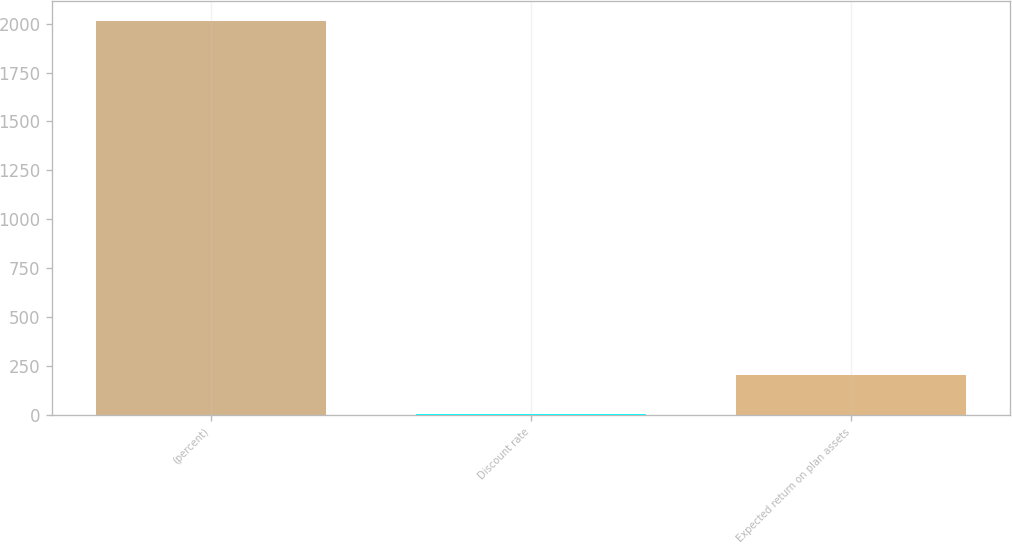Convert chart to OTSL. <chart><loc_0><loc_0><loc_500><loc_500><bar_chart><fcel>(percent)<fcel>Discount rate<fcel>Expected return on plan assets<nl><fcel>2015<fcel>4.38<fcel>205.44<nl></chart> 